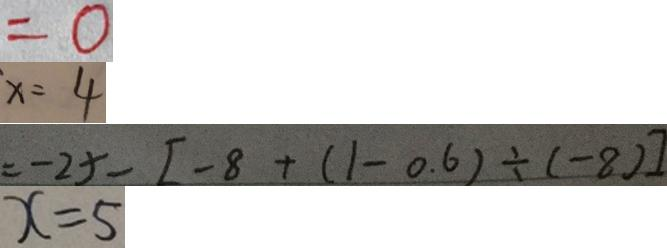<formula> <loc_0><loc_0><loc_500><loc_500>= 0 
 x = 4 
 = - 2 5 - [ - 8 + ( 1 - 0 . 6 ) \div ( - 8 ) ] 
 x = 5</formula> 